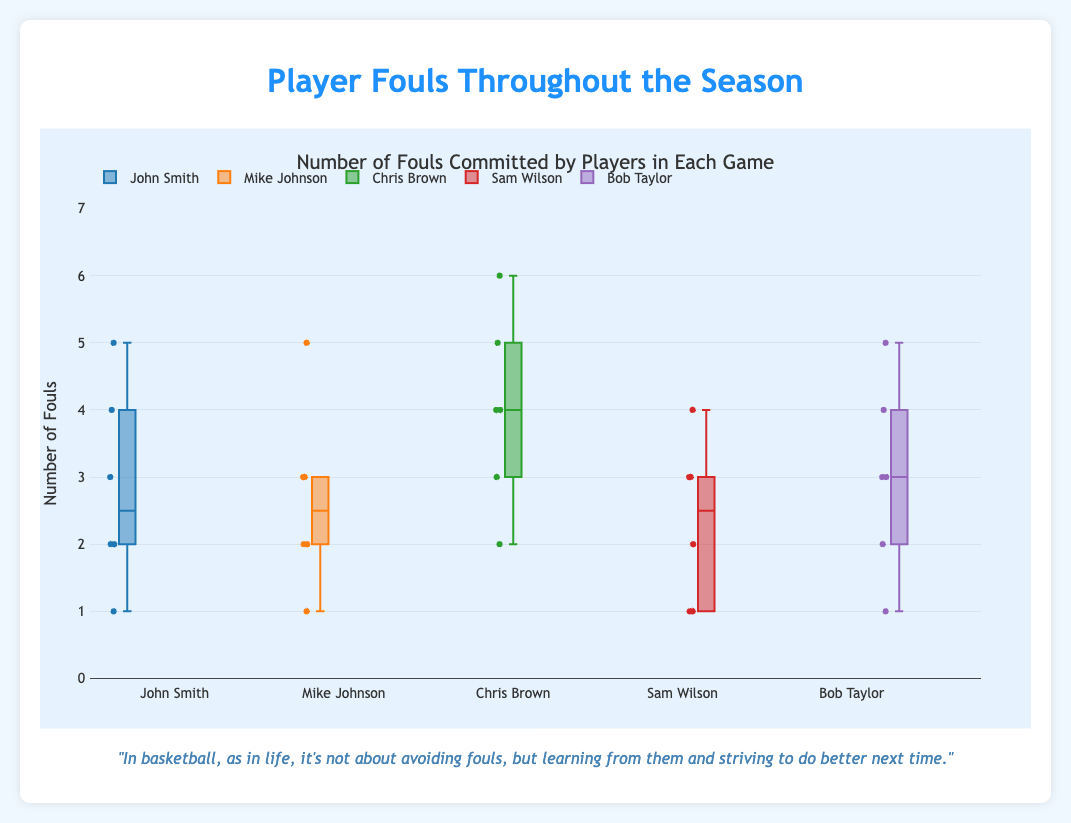What is the title of the box plot? The title is located at the upper part of the figure. It provides a brief description of what the data is about.
Answer: Number of Fouls Committed by Players in Each Game Throughout the Season What is the y-axis representing? The y-axis label indicates the parameter being measured in the box plot.
Answer: Number of Fouls Which player has the highest single game foul count? By examining the highest values on the y-axis for each player's box, we can identify the maximum foul count recorded.
Answer: Chris Brown Which player has the widest range of fouls? The range of fouls for each player can be observed in the length of the box plot. The player with the longest box plot range has the widest range.
Answer: John Smith How does the median number of fouls for Mike Johnson compare to that of Sam Wilson? The median for each player can be located by finding the line within their respective boxes. By comparing the positions of these lines for Mike Johnson and Sam Wilson, we can see which one is higher.
Answer: Mike Johnson's median is higher than Sam Wilson's Are there any players whose fouls vary significantly from one game to another? Players with a large spread in their data points, indicated by the distance between the lowest and highest values, show significant variation in their fouls.
Answer: John Smith Which player has the lowest median fouls? The median fouls for each player are identified by the central line in their box plots. The player with the lowest median line has the lowest median fouls.
Answer: Sam Wilson Which players have their interquartile ranges (IQR) overlapping? The interquartile range is represented by the box itself. Overlapping boxes between players suggest that their IQRs overlap. A visual inspection shows overlapping boxes.
Answer: Multiple players, such as John Smith and Chris Brown Considering the maximum values, how do Chris Brown and Bob Taylor compare? The maximum value for each player is identified by the uppermost point of their whisker or outliers. Chris Brown and Bob Taylor's maximum values can be directly compared by looking at these points.
Answer: Chris Brown has a higher maximum value than Bob Taylor Is there a player who consistently commits relatively few fouls? A player with consistently low foul counts will have a box plot that is closer to the lower end of the y-axis with a small spread.
Answer: Sam Wilson 